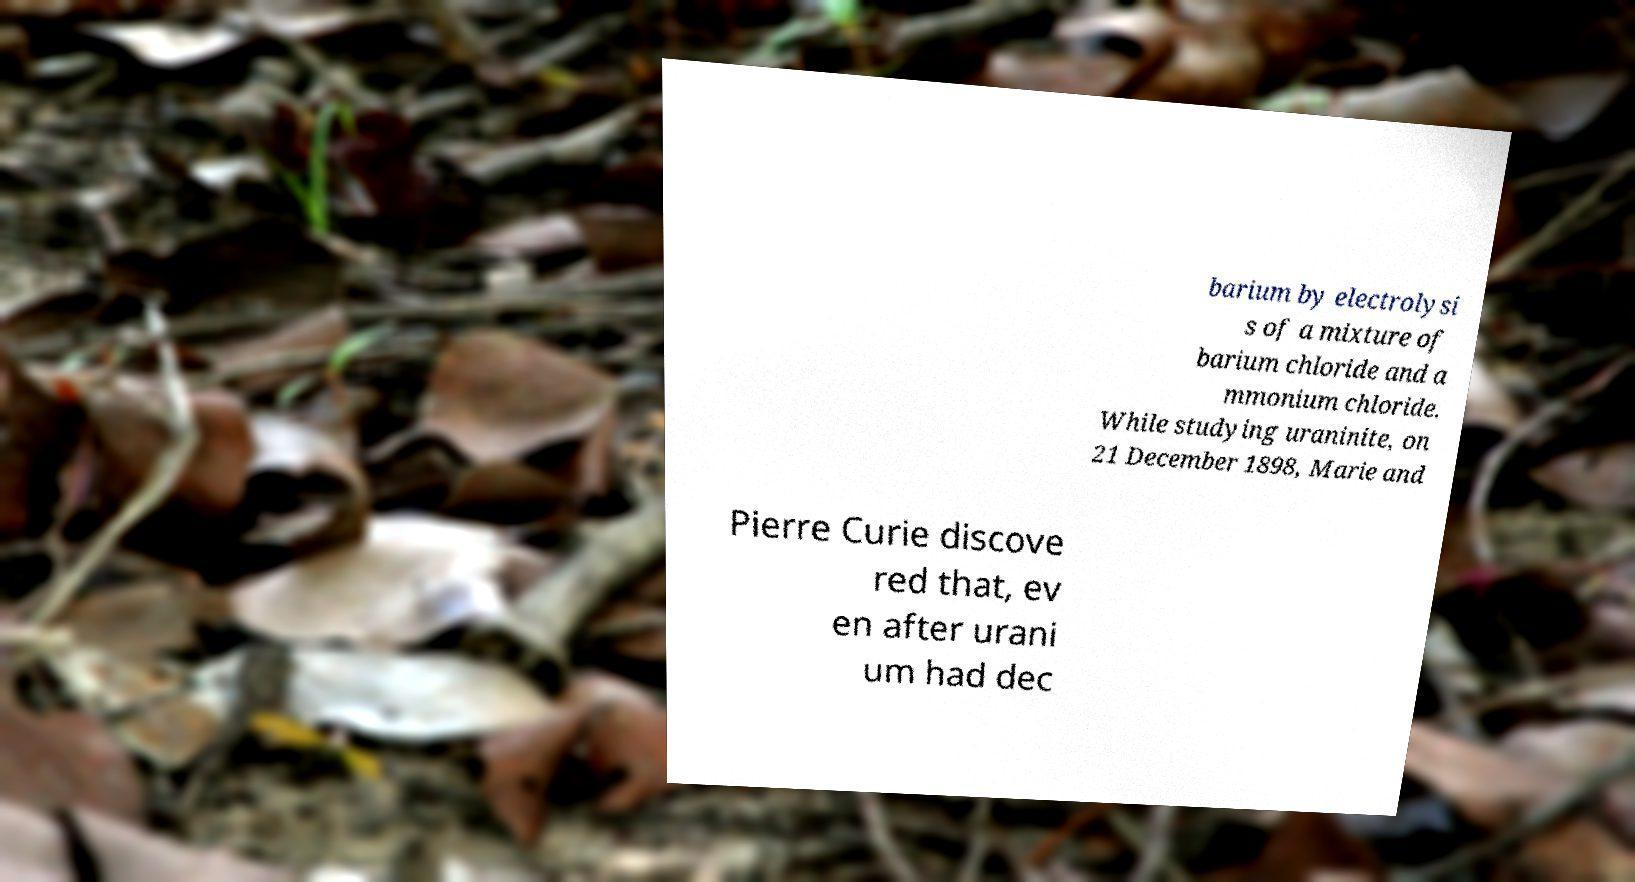Please read and relay the text visible in this image. What does it say? barium by electrolysi s of a mixture of barium chloride and a mmonium chloride. While studying uraninite, on 21 December 1898, Marie and Pierre Curie discove red that, ev en after urani um had dec 